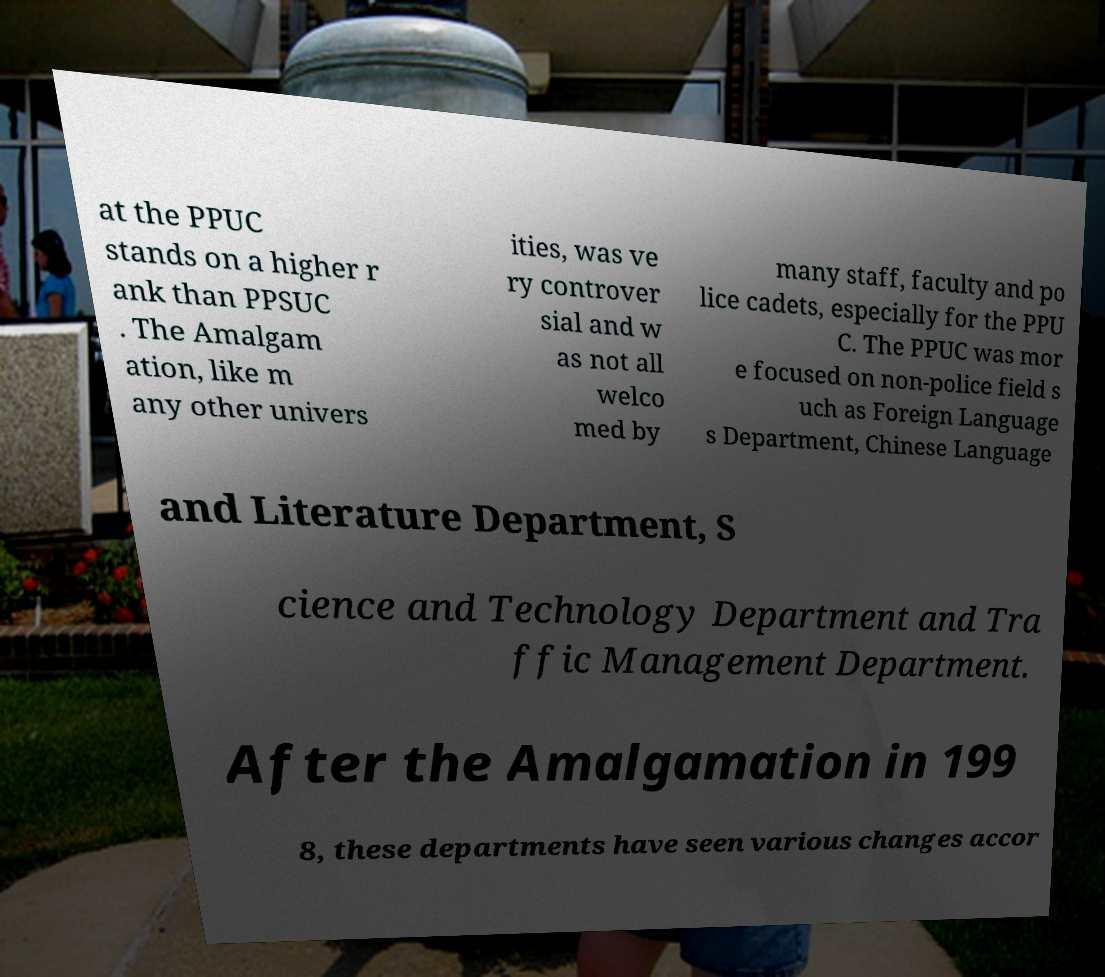Can you read and provide the text displayed in the image?This photo seems to have some interesting text. Can you extract and type it out for me? at the PPUC stands on a higher r ank than PPSUC . The Amalgam ation, like m any other univers ities, was ve ry controver sial and w as not all welco med by many staff, faculty and po lice cadets, especially for the PPU C. The PPUC was mor e focused on non-police field s uch as Foreign Language s Department, Chinese Language and Literature Department, S cience and Technology Department and Tra ffic Management Department. After the Amalgamation in 199 8, these departments have seen various changes accor 